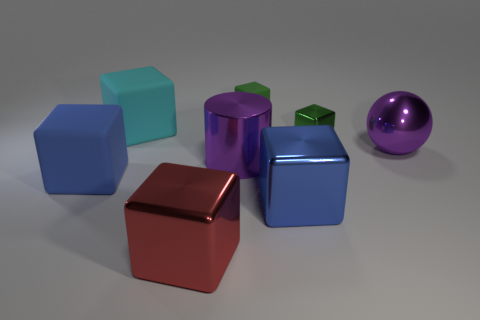Subtract all green cubes. How many were subtracted if there are1green cubes left? 1 Subtract all cyan rubber blocks. How many blocks are left? 5 Subtract all cyan cubes. How many cubes are left? 5 Subtract all yellow cubes. Subtract all purple cylinders. How many cubes are left? 6 Add 1 green rubber blocks. How many objects exist? 9 Subtract all cylinders. How many objects are left? 7 Add 8 green metallic objects. How many green metallic objects exist? 9 Subtract 0 blue cylinders. How many objects are left? 8 Subtract all blocks. Subtract all large blue rubber things. How many objects are left? 1 Add 5 purple shiny spheres. How many purple shiny spheres are left? 6 